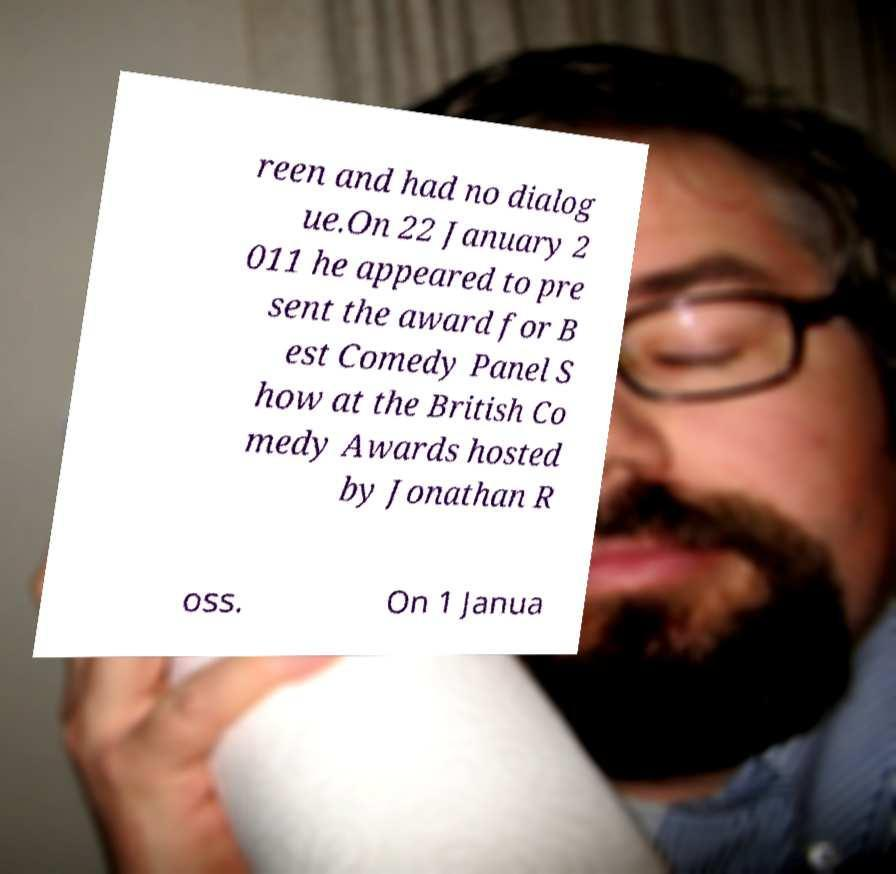Could you assist in decoding the text presented in this image and type it out clearly? reen and had no dialog ue.On 22 January 2 011 he appeared to pre sent the award for B est Comedy Panel S how at the British Co medy Awards hosted by Jonathan R oss. On 1 Janua 